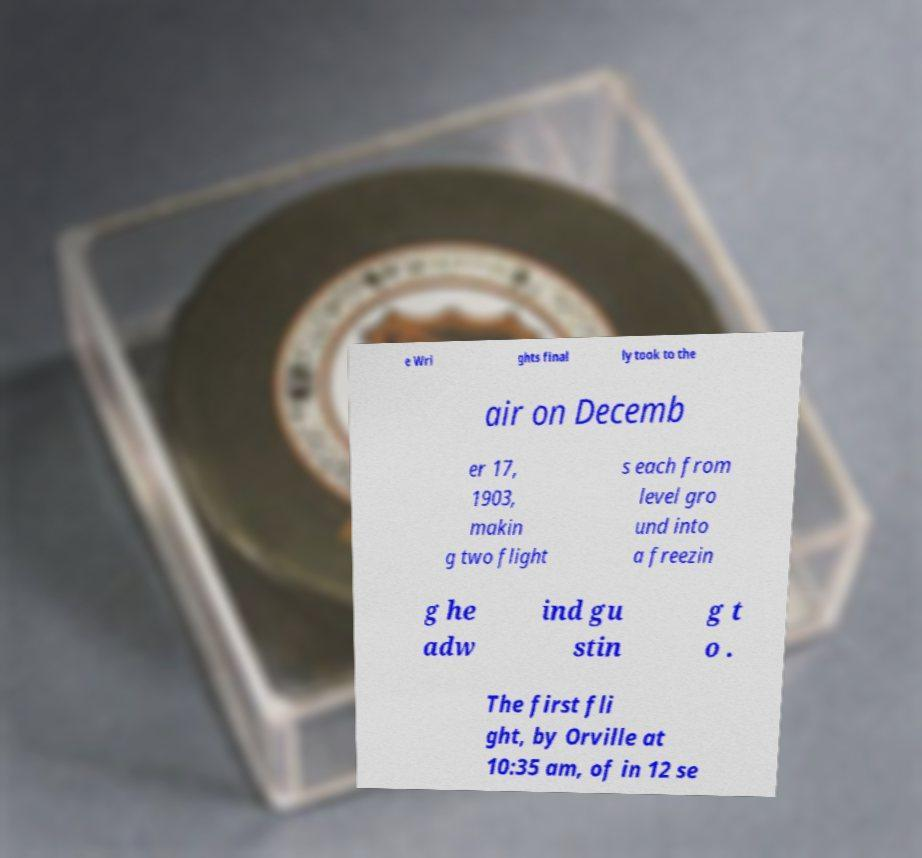Can you read and provide the text displayed in the image?This photo seems to have some interesting text. Can you extract and type it out for me? e Wri ghts final ly took to the air on Decemb er 17, 1903, makin g two flight s each from level gro und into a freezin g he adw ind gu stin g t o . The first fli ght, by Orville at 10:35 am, of in 12 se 